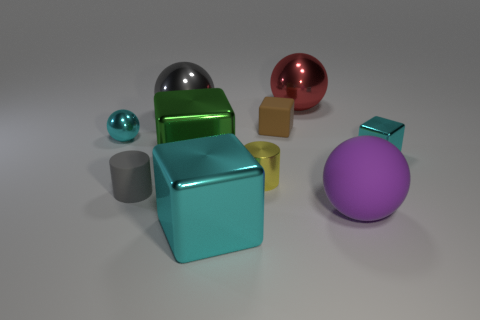Subtract 1 blocks. How many blocks are left? 3 Subtract all cylinders. How many objects are left? 8 Add 5 big blue things. How many big blue things exist? 5 Subtract 0 purple cylinders. How many objects are left? 10 Subtract all green shiny things. Subtract all gray rubber cylinders. How many objects are left? 8 Add 3 large gray balls. How many large gray balls are left? 4 